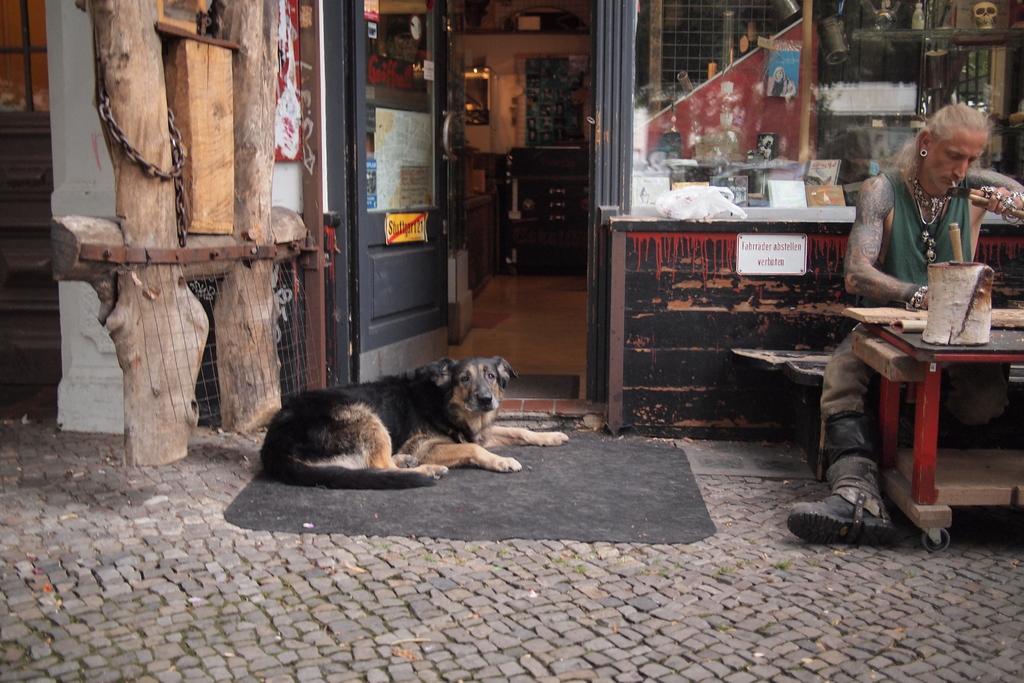Can you describe this image briefly? On the right side, there is a person sitting and working. In front of him, there is a table on which there are some objects. On the left side, there is a dog on a mat. Beside this dog, there are wooden poles. In the background, there is a door of a building and there are some objects. 